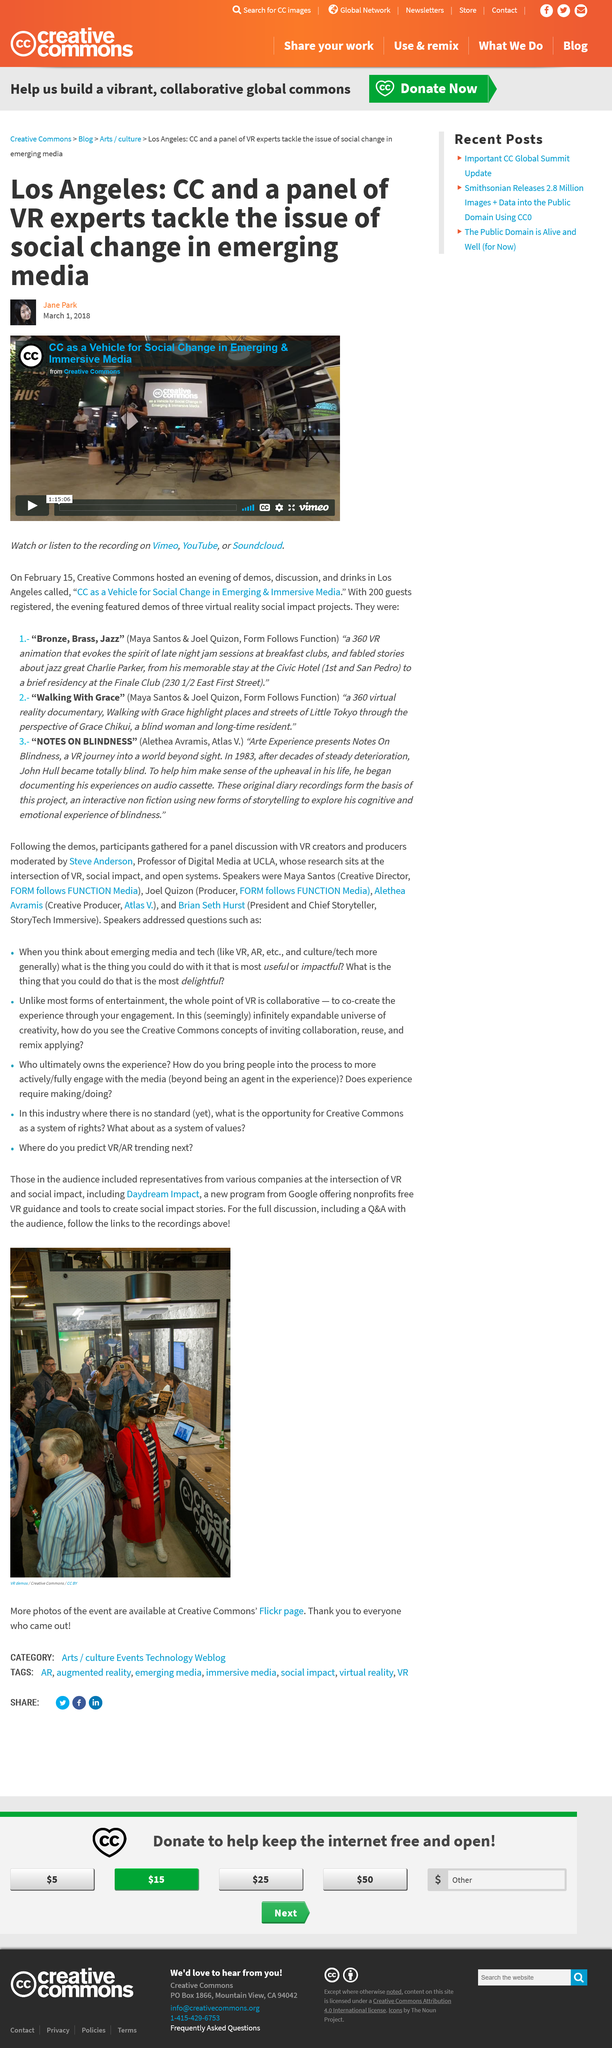Point out several critical features in this image. The Creative Commons and a panel of VR experts are working to address social change in emerging media. The author of this article is Jane Park. The recording can be viewed on the platforms of Vimeo, YouTube, or Soundcloud. 